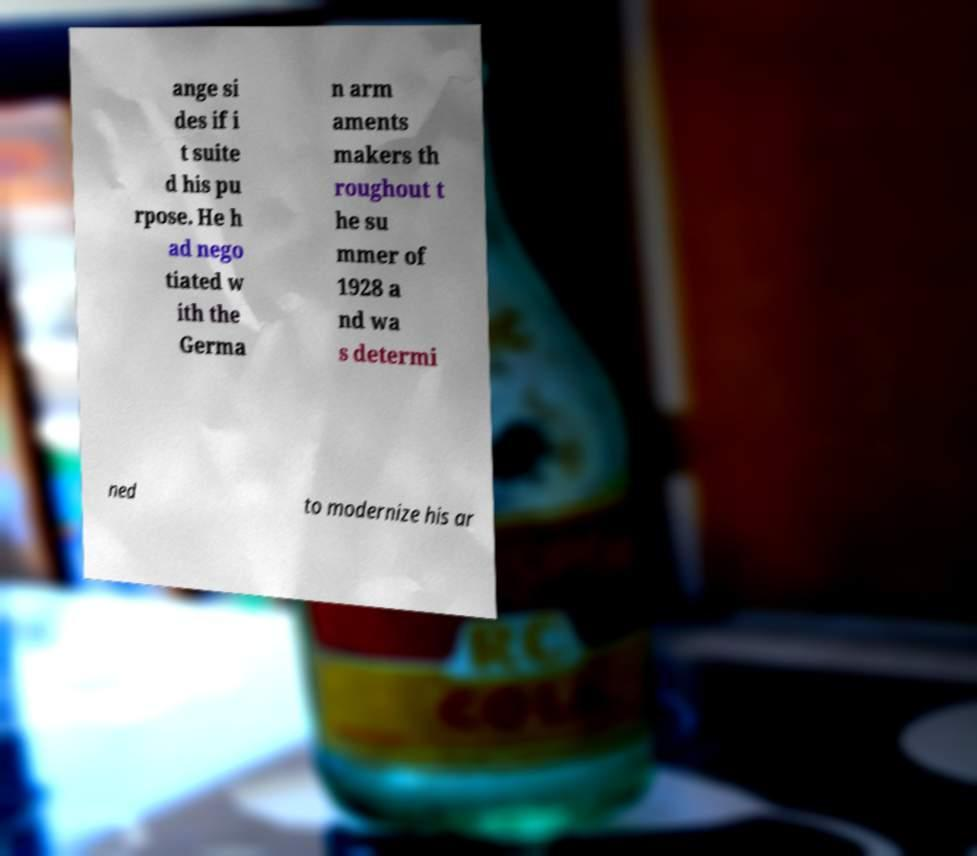Can you accurately transcribe the text from the provided image for me? ange si des if i t suite d his pu rpose. He h ad nego tiated w ith the Germa n arm aments makers th roughout t he su mmer of 1928 a nd wa s determi ned to modernize his ar 